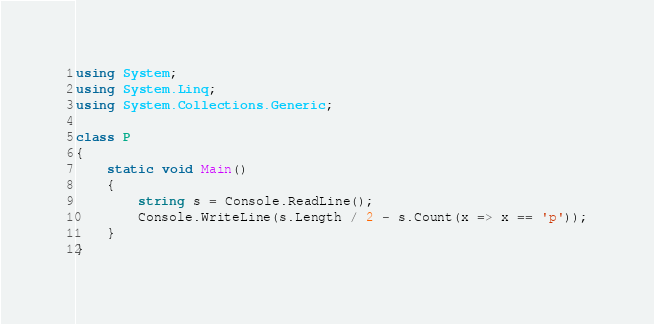<code> <loc_0><loc_0><loc_500><loc_500><_C#_>using System; 
using System.Linq;
using System.Collections.Generic;

class P
{
    static void Main()
    {
        string s = Console.ReadLine();
        Console.WriteLine(s.Length / 2 - s.Count(x => x == 'p'));
    }
}</code> 